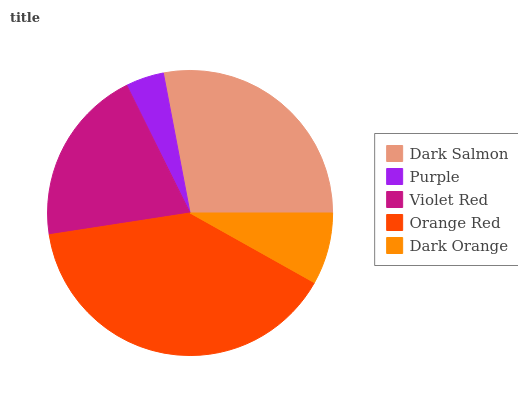Is Purple the minimum?
Answer yes or no. Yes. Is Orange Red the maximum?
Answer yes or no. Yes. Is Violet Red the minimum?
Answer yes or no. No. Is Violet Red the maximum?
Answer yes or no. No. Is Violet Red greater than Purple?
Answer yes or no. Yes. Is Purple less than Violet Red?
Answer yes or no. Yes. Is Purple greater than Violet Red?
Answer yes or no. No. Is Violet Red less than Purple?
Answer yes or no. No. Is Violet Red the high median?
Answer yes or no. Yes. Is Violet Red the low median?
Answer yes or no. Yes. Is Dark Salmon the high median?
Answer yes or no. No. Is Dark Orange the low median?
Answer yes or no. No. 